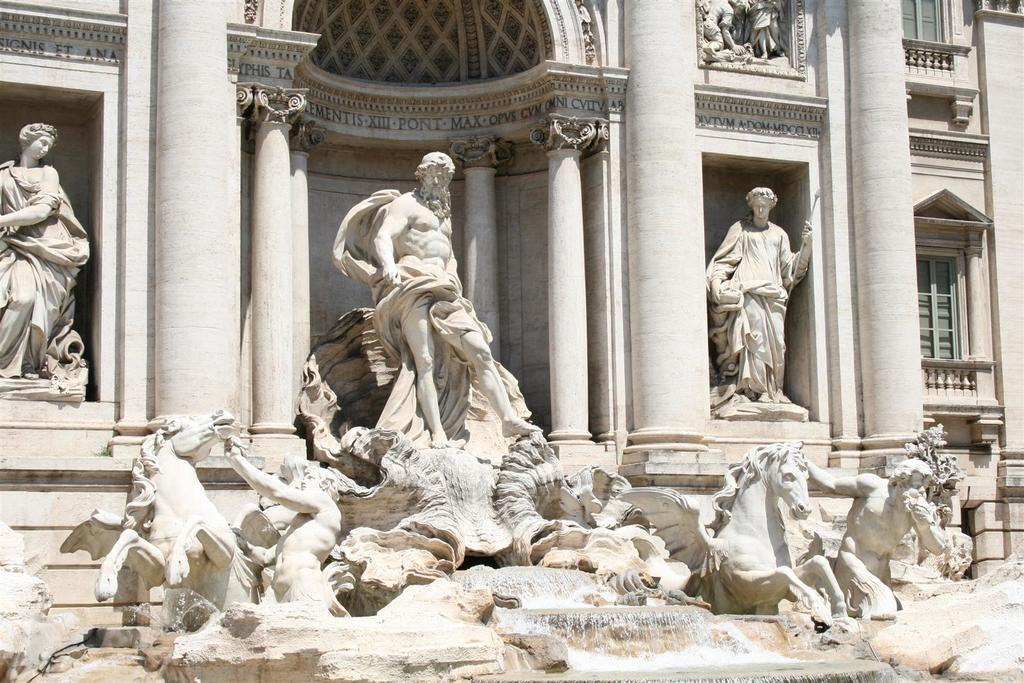What is the main subject of the image? The main subject of the image is a sculpture. What does the sculpture depict? The sculpture depicts persons and horses. Are there any other elements in the sculpture besides the persons and horses? Yes, there are other objects in the sculpture. What can be seen in the right corner of the image? There is a building in the right corner of the image. How does the seed contribute to the sculpture's design? There is no mention of a seed in the image or the sculpture's design. 